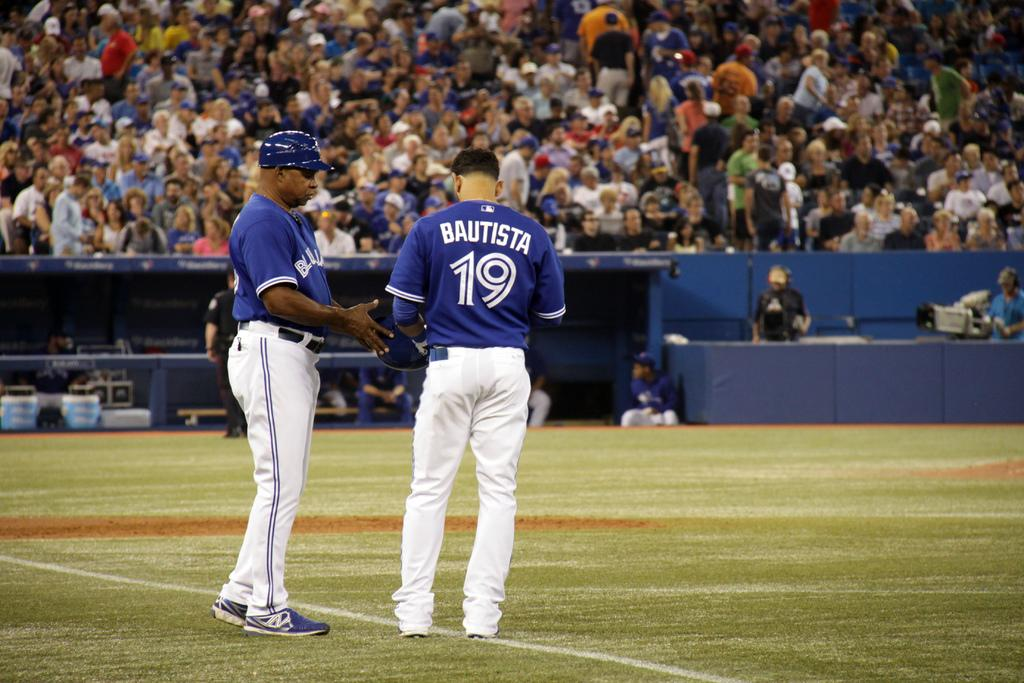<image>
Render a clear and concise summary of the photo. Player Bautista wearing number 19 with another teammate. 